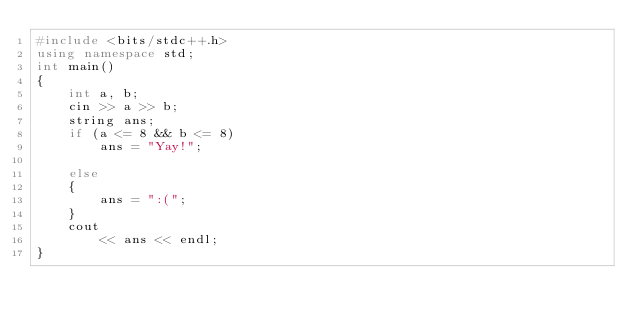<code> <loc_0><loc_0><loc_500><loc_500><_C++_>#include <bits/stdc++.h>
using namespace std;
int main()
{
    int a, b;
    cin >> a >> b;
    string ans;
    if (a <= 8 && b <= 8)
        ans = "Yay!";

    else
    {
        ans = ":(";
    }
    cout
        << ans << endl;
}
</code> 